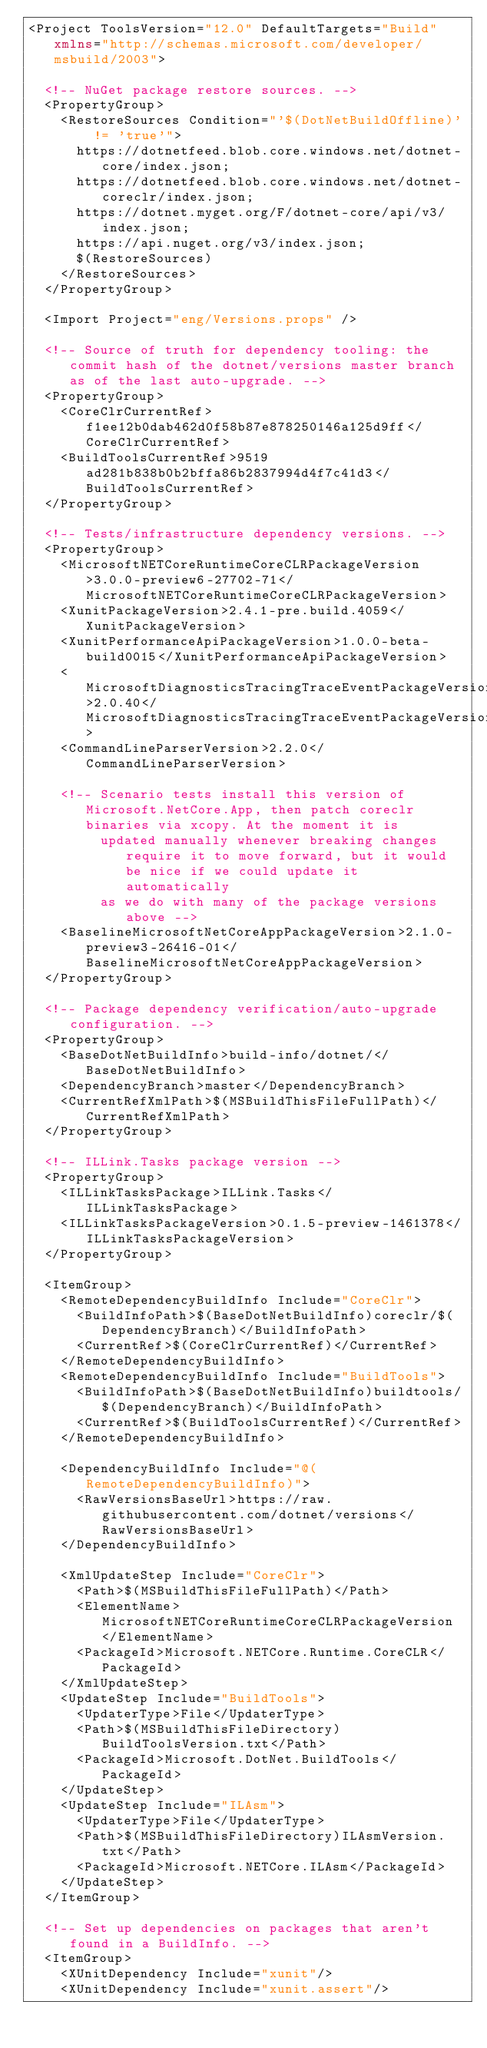Convert code to text. <code><loc_0><loc_0><loc_500><loc_500><_XML_><Project ToolsVersion="12.0" DefaultTargets="Build" xmlns="http://schemas.microsoft.com/developer/msbuild/2003">

  <!-- NuGet package restore sources. -->
  <PropertyGroup>
    <RestoreSources Condition="'$(DotNetBuildOffline)' != 'true'">
      https://dotnetfeed.blob.core.windows.net/dotnet-core/index.json;
      https://dotnetfeed.blob.core.windows.net/dotnet-coreclr/index.json;
      https://dotnet.myget.org/F/dotnet-core/api/v3/index.json;
      https://api.nuget.org/v3/index.json;
      $(RestoreSources)
    </RestoreSources>
  </PropertyGroup>

  <Import Project="eng/Versions.props" />

  <!-- Source of truth for dependency tooling: the commit hash of the dotnet/versions master branch as of the last auto-upgrade. -->
  <PropertyGroup>
    <CoreClrCurrentRef>f1ee12b0dab462d0f58b87e878250146a125d9ff</CoreClrCurrentRef>
    <BuildToolsCurrentRef>9519ad281b838b0b2bffa86b2837994d4f7c41d3</BuildToolsCurrentRef>
  </PropertyGroup>

  <!-- Tests/infrastructure dependency versions. -->
  <PropertyGroup>
    <MicrosoftNETCoreRuntimeCoreCLRPackageVersion>3.0.0-preview6-27702-71</MicrosoftNETCoreRuntimeCoreCLRPackageVersion>
    <XunitPackageVersion>2.4.1-pre.build.4059</XunitPackageVersion>
    <XunitPerformanceApiPackageVersion>1.0.0-beta-build0015</XunitPerformanceApiPackageVersion>
    <MicrosoftDiagnosticsTracingTraceEventPackageVersion>2.0.40</MicrosoftDiagnosticsTracingTraceEventPackageVersion>
    <CommandLineParserVersion>2.2.0</CommandLineParserVersion>

    <!-- Scenario tests install this version of Microsoft.NetCore.App, then patch coreclr binaries via xcopy. At the moment it is
         updated manually whenever breaking changes require it to move forward, but it would be nice if we could update it automatically
         as we do with many of the package versions above -->
    <BaselineMicrosoftNetCoreAppPackageVersion>2.1.0-preview3-26416-01</BaselineMicrosoftNetCoreAppPackageVersion>
  </PropertyGroup>

  <!-- Package dependency verification/auto-upgrade configuration. -->
  <PropertyGroup>
    <BaseDotNetBuildInfo>build-info/dotnet/</BaseDotNetBuildInfo>
    <DependencyBranch>master</DependencyBranch>
    <CurrentRefXmlPath>$(MSBuildThisFileFullPath)</CurrentRefXmlPath>
  </PropertyGroup>

  <!-- ILLink.Tasks package version -->
  <PropertyGroup>
    <ILLinkTasksPackage>ILLink.Tasks</ILLinkTasksPackage>
    <ILLinkTasksPackageVersion>0.1.5-preview-1461378</ILLinkTasksPackageVersion>
  </PropertyGroup>

  <ItemGroup>
    <RemoteDependencyBuildInfo Include="CoreClr">
      <BuildInfoPath>$(BaseDotNetBuildInfo)coreclr/$(DependencyBranch)</BuildInfoPath>
      <CurrentRef>$(CoreClrCurrentRef)</CurrentRef>
    </RemoteDependencyBuildInfo>
    <RemoteDependencyBuildInfo Include="BuildTools">
      <BuildInfoPath>$(BaseDotNetBuildInfo)buildtools/$(DependencyBranch)</BuildInfoPath>
      <CurrentRef>$(BuildToolsCurrentRef)</CurrentRef>
    </RemoteDependencyBuildInfo>

    <DependencyBuildInfo Include="@(RemoteDependencyBuildInfo)">
      <RawVersionsBaseUrl>https://raw.githubusercontent.com/dotnet/versions</RawVersionsBaseUrl>
    </DependencyBuildInfo>

    <XmlUpdateStep Include="CoreClr">
      <Path>$(MSBuildThisFileFullPath)</Path>
      <ElementName>MicrosoftNETCoreRuntimeCoreCLRPackageVersion</ElementName>
      <PackageId>Microsoft.NETCore.Runtime.CoreCLR</PackageId>
    </XmlUpdateStep>
    <UpdateStep Include="BuildTools">
      <UpdaterType>File</UpdaterType>
      <Path>$(MSBuildThisFileDirectory)BuildToolsVersion.txt</Path>
      <PackageId>Microsoft.DotNet.BuildTools</PackageId>
    </UpdateStep>
    <UpdateStep Include="ILAsm">
      <UpdaterType>File</UpdaterType>
      <Path>$(MSBuildThisFileDirectory)ILAsmVersion.txt</Path>
      <PackageId>Microsoft.NETCore.ILAsm</PackageId>
    </UpdateStep>
  </ItemGroup>

  <!-- Set up dependencies on packages that aren't found in a BuildInfo. -->
  <ItemGroup>
    <XUnitDependency Include="xunit"/>
    <XUnitDependency Include="xunit.assert"/></code> 